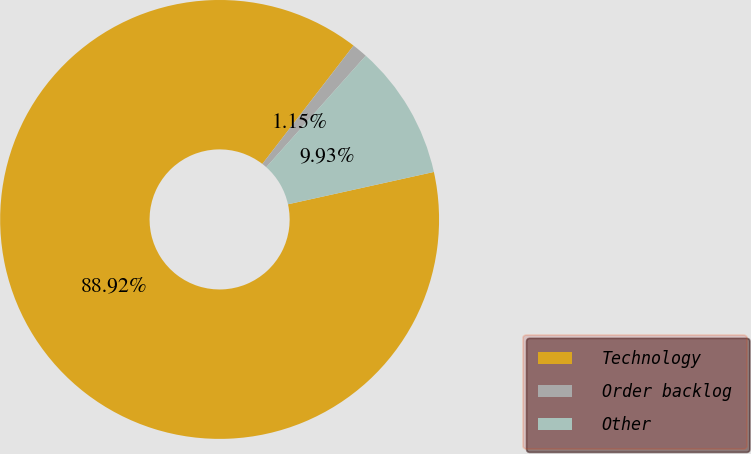Convert chart. <chart><loc_0><loc_0><loc_500><loc_500><pie_chart><fcel>Technology<fcel>Order backlog<fcel>Other<nl><fcel>88.91%<fcel>1.15%<fcel>9.93%<nl></chart> 